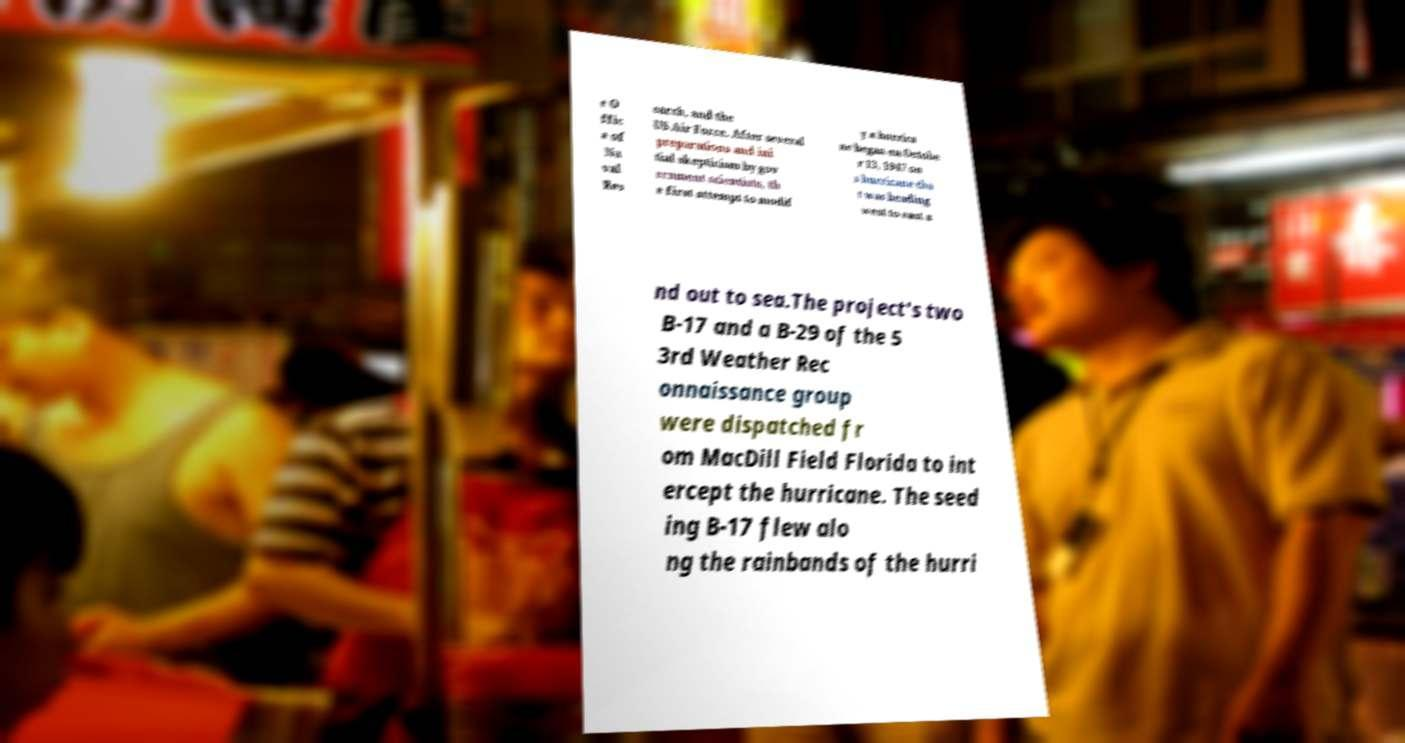I need the written content from this picture converted into text. Can you do that? e O ffic e of Na val Res earch, and the US Air Force. After several preparations and ini tial skepticism by gov ernment scientists, th e first attempt to modif y a hurrica ne began on Octobe r 13, 1947 on a hurricane tha t was heading west to east a nd out to sea.The project's two B-17 and a B-29 of the 5 3rd Weather Rec onnaissance group were dispatched fr om MacDill Field Florida to int ercept the hurricane. The seed ing B-17 flew alo ng the rainbands of the hurri 